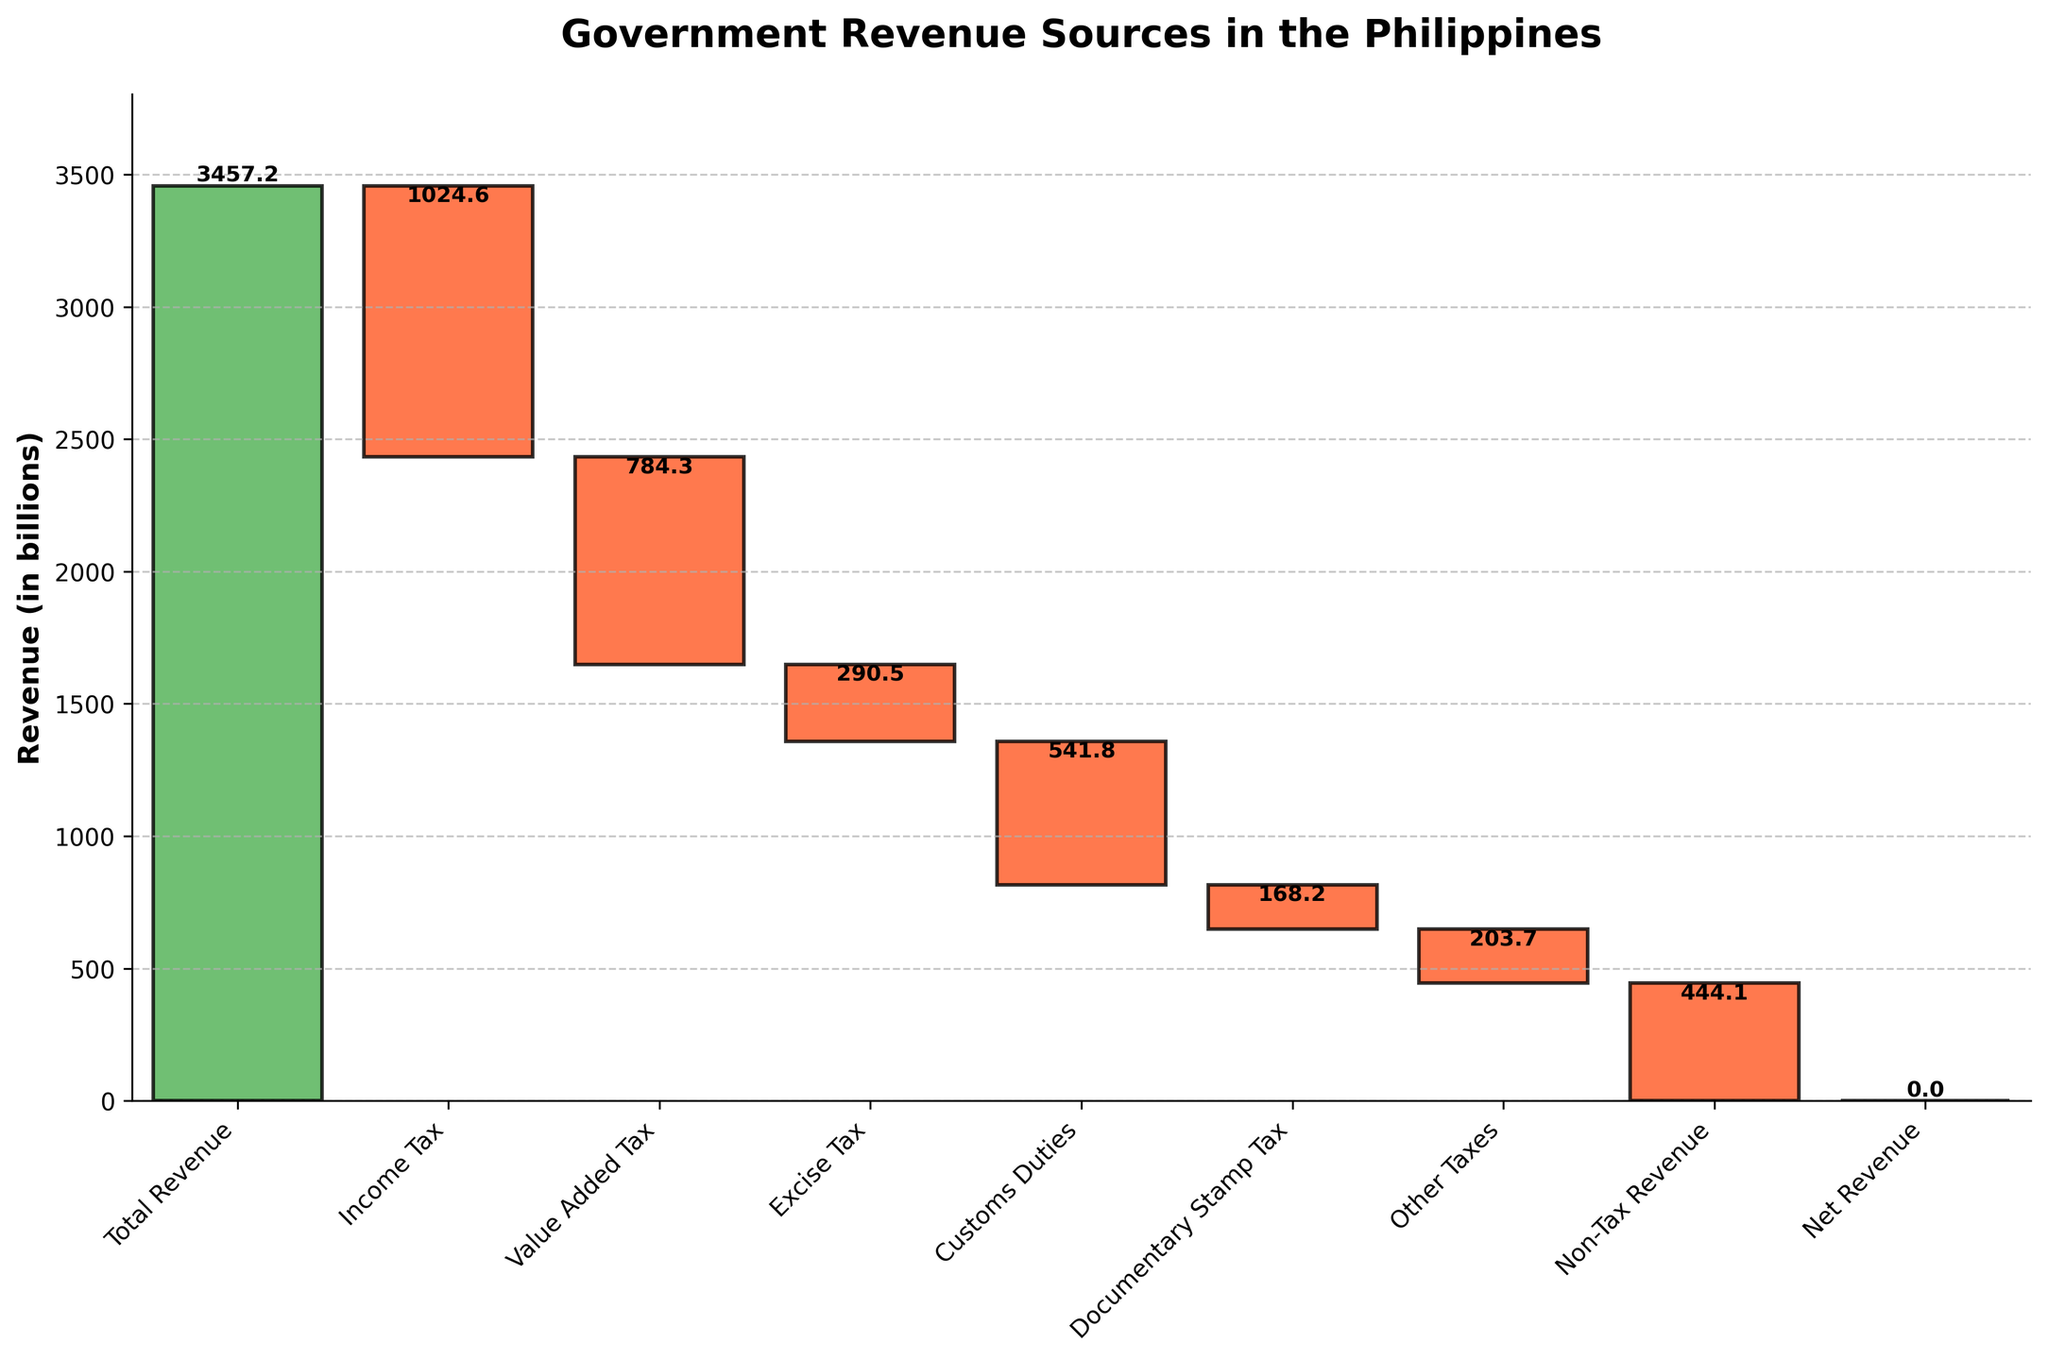What is the title of the chart? The title of the chart is prominently displayed at the top, providing an overview of what the figure represents.
Answer: Government Revenue Sources in the Philippines Which tax contributes the most to the revenue drop? By looking at the length of the bars that go downward (red bars), we can see which one has the largest absolute value.
Answer: Income Tax What are the colors used in the chart for different types of values? The colors used in the chart are green for the Total Revenue and Net Revenue, red for negative values like taxes, and blue for other positive values.
Answer: Green, Red, Blue What is the combined revenue loss from Value Added Tax and Customs Duties? Add the absolute values of Value Added Tax (-784.3) and Customs Duties (-541.8). The combined revenue loss is 784.3 + 541.8.
Answer: 1326.1 Which tax category contributes the least to revenue, and what is its value? By comparing the values of all tax categories, the smallest absolute value can be identified.
Answer: Documentary Stamp Tax, -168.2 How much more is the revenue loss from Income Tax compared to Excise Tax? Subtract the value of Excise Tax from Income Tax, which is -1024.6 - (-290.5).
Answer: 734.1 What is the net effect of all the other taxes combined (excluding Total Revenue and Net Revenue)? Sum up the values of all tax categories except Total Revenue and Net Revenue: -1024.6 + (-784.3) + (-290.5) + (-541.8) + (-168.2) + (-203.7) + (-444.1).
Answer: -3457.2 What is the range of revenue loss from the tax categories shown? Identify the highest and lowest values among the tax categories and subtract the smallest negative value from the largest negative value: -1024.6 to -168.2, range is -168.2 - (-1024.6).
Answer: 856.4 